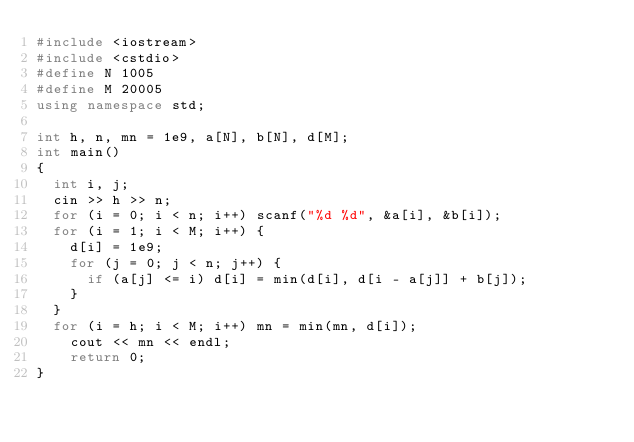<code> <loc_0><loc_0><loc_500><loc_500><_C++_>#include <iostream>
#include <cstdio>
#define N 1005
#define M 20005
using namespace std;

int h, n, mn = 1e9, a[N], b[N], d[M];
int main()
{
	int i, j;
	cin >> h >> n;
	for (i = 0; i < n; i++) scanf("%d %d", &a[i], &b[i]);
	for (i = 1; i < M; i++) {
		d[i] = 1e9;
		for (j = 0; j < n; j++) {
			if (a[j] <= i) d[i] = min(d[i], d[i - a[j]] + b[j]);
		}
	}
	for (i = h; i < M; i++) mn = min(mn, d[i]);
    cout << mn << endl;
    return 0;
}</code> 